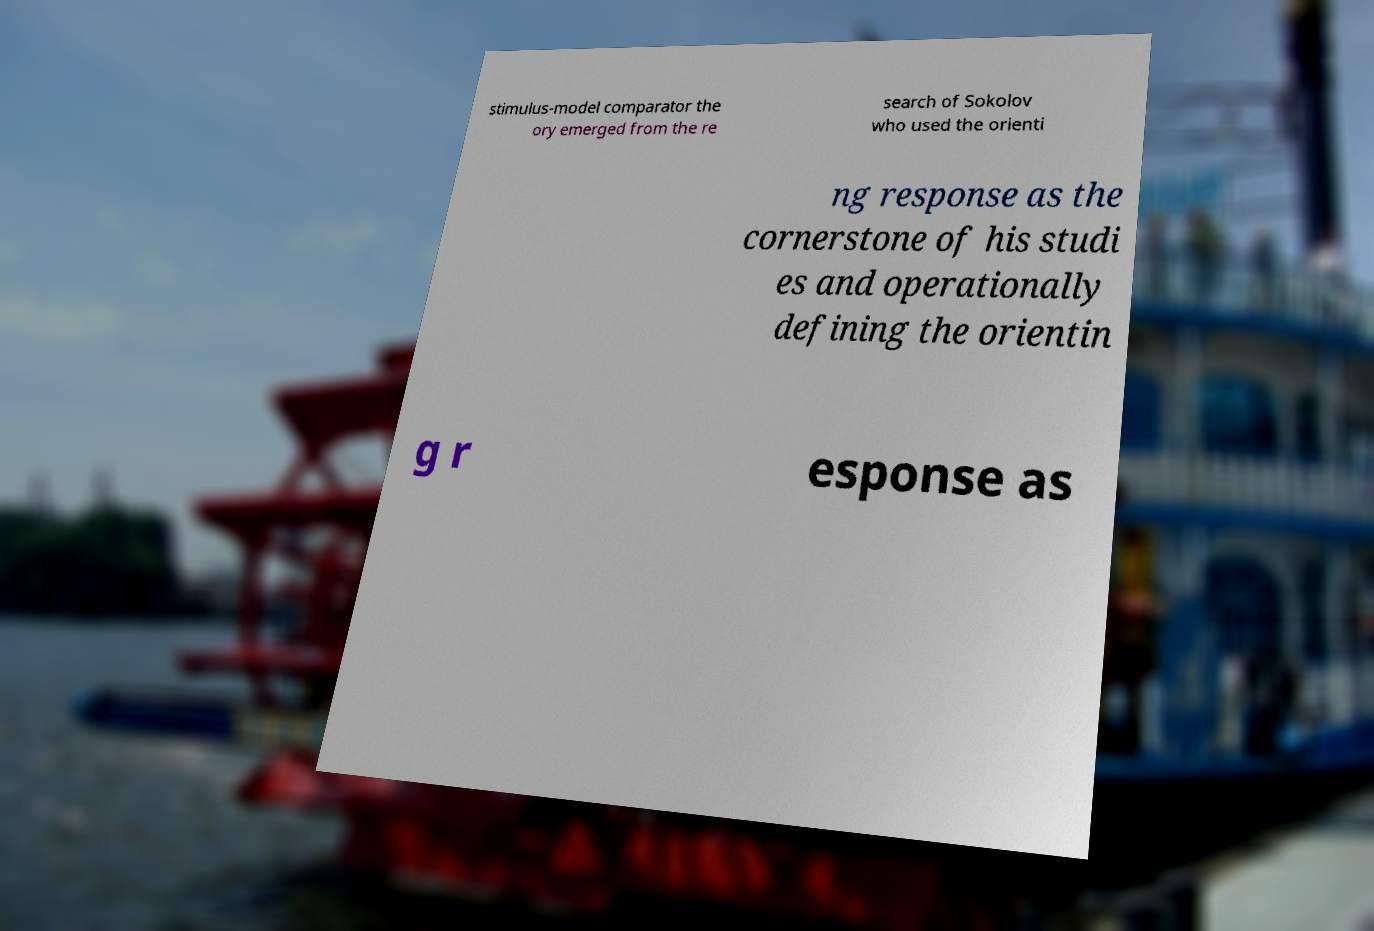Can you read and provide the text displayed in the image?This photo seems to have some interesting text. Can you extract and type it out for me? stimulus-model comparator the ory emerged from the re search of Sokolov who used the orienti ng response as the cornerstone of his studi es and operationally defining the orientin g r esponse as 